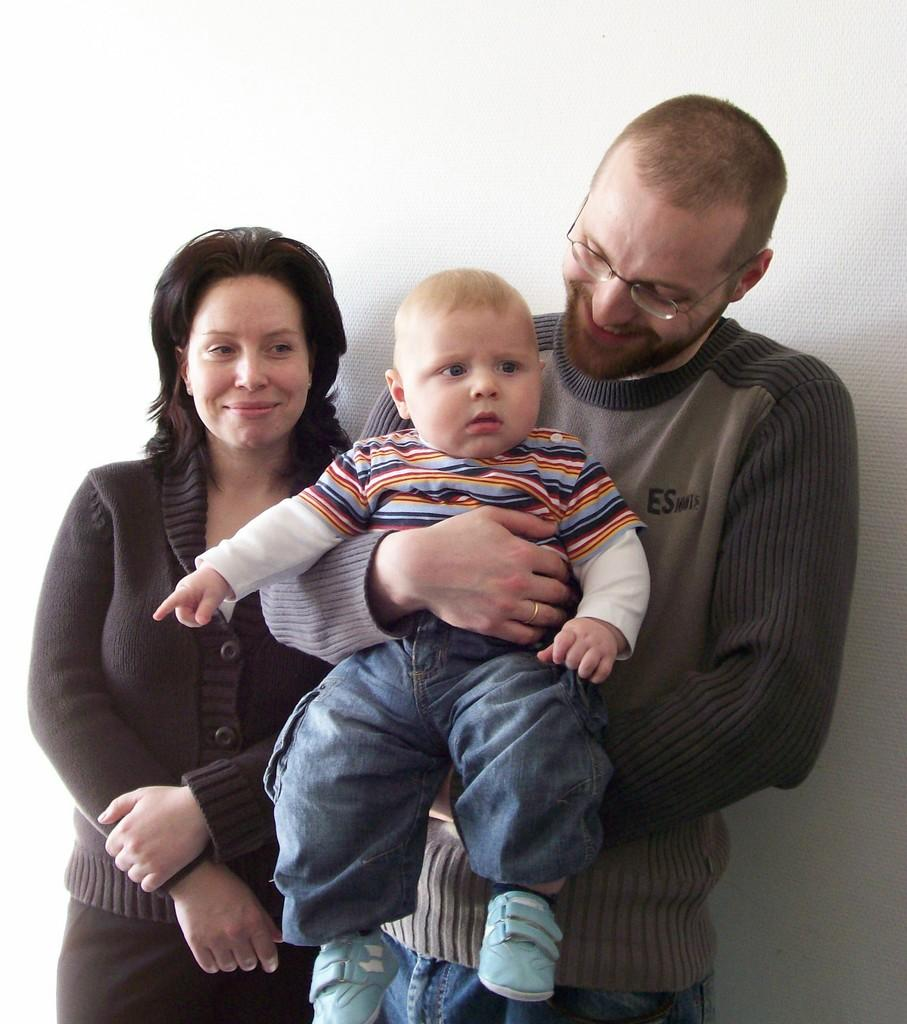Who are the people in the image? There is a woman and a man in the image. What is the man doing in the image? The man is holding a baby in the image. Can you describe the man's appearance? The man is wearing spectacles and is smiling. What is the color of the background in the image? The background of the image is white. In which direction is the man measuring the baby's temper in the image? There is no indication in the image that the man is measuring the baby's temper or using any measuring tools. 